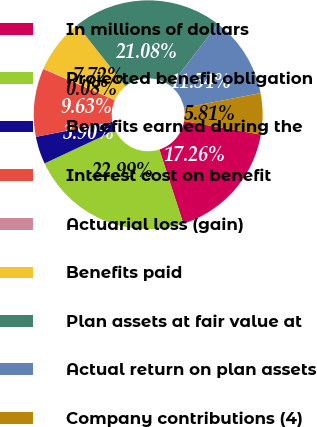Convert chart. <chart><loc_0><loc_0><loc_500><loc_500><pie_chart><fcel>In millions of dollars<fcel>Projected benefit obligation<fcel>Benefits earned during the<fcel>Interest cost on benefit<fcel>Actuarial loss (gain)<fcel>Benefits paid<fcel>Plan assets at fair value at<fcel>Actual return on plan assets<fcel>Company contributions (4)<nl><fcel>17.26%<fcel>22.99%<fcel>3.9%<fcel>9.63%<fcel>0.08%<fcel>7.72%<fcel>21.08%<fcel>11.54%<fcel>5.81%<nl></chart> 